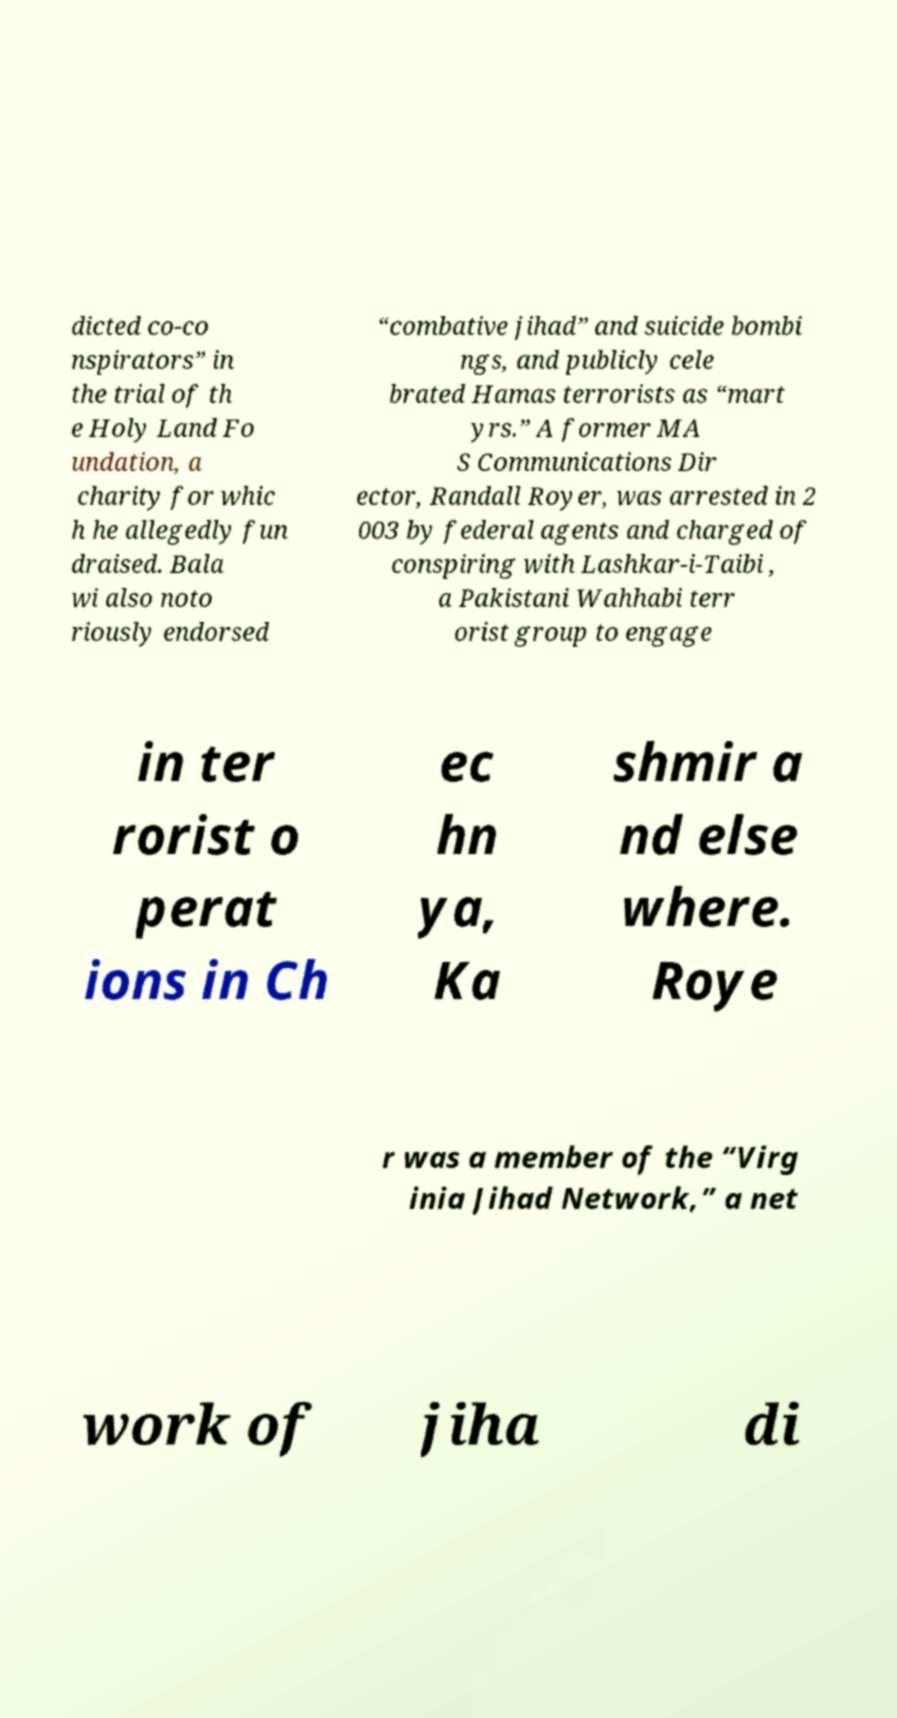Please identify and transcribe the text found in this image. dicted co-co nspirators” in the trial of th e Holy Land Fo undation, a charity for whic h he allegedly fun draised. Bala wi also noto riously endorsed “combative jihad” and suicide bombi ngs, and publicly cele brated Hamas terrorists as “mart yrs.” A former MA S Communications Dir ector, Randall Royer, was arrested in 2 003 by federal agents and charged of conspiring with Lashkar-i-Taibi , a Pakistani Wahhabi terr orist group to engage in ter rorist o perat ions in Ch ec hn ya, Ka shmir a nd else where. Roye r was a member of the “Virg inia Jihad Network,” a net work of jiha di 